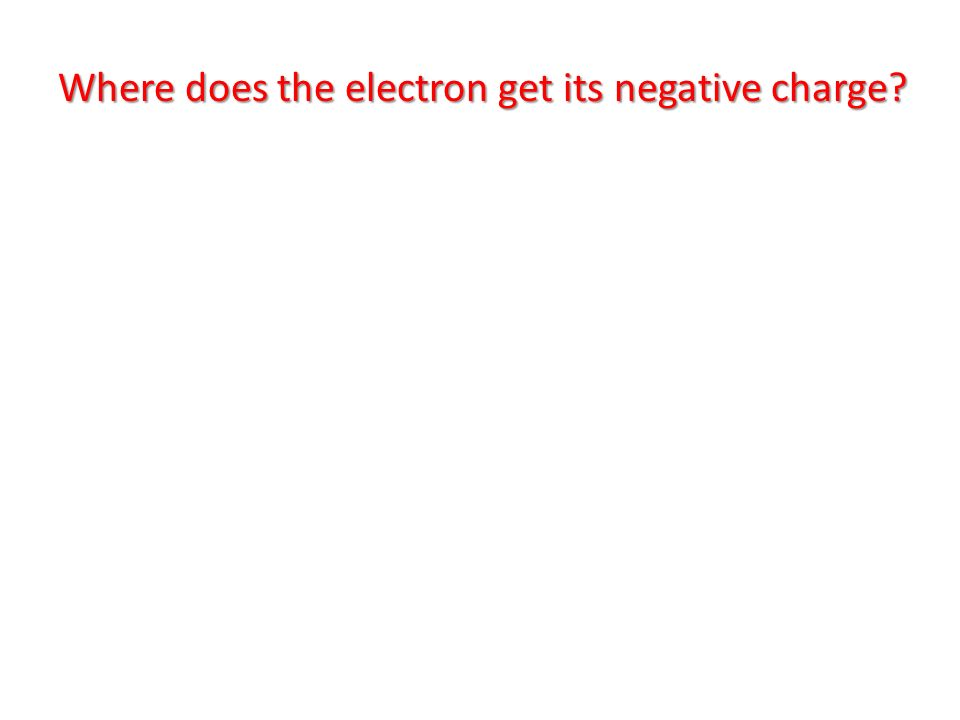Imagine if the electron's charge could be visibly seen, how would you creatively represent this concept visually? If the electron's charge could be visually represented, one creative way to depict this might be through a glowing aura or field surrounding the electron. Picture a tiny particle, the electron, with a bright, pulsing blue aura representing its negative charge. The intensity of the glow could vary to indicate the strength of the charge field. In a more artistic representation, streams or sparks of energy could emanate from the electron, swirling in dynamic patterns that reflect the electromagnetic interactions it engages in. This visual could be set against a contrasting background, such as a dark or starry space, to emphasize the electron's energy and importance in atomic structures. This sort of visual could be used in educational materials to make the abstract concept of charge more tangible and engaging. In a scientific setting, how else might we visually illustrate the consequences or interactions of an electron's charge? In a scientific setting, the consequences or interactions of an electron's charge could be illustrated using field lines in a diagram, showing its influence in an electric field. Another visual method could be through simulations depicting electrons moving within an atom, highlighting their interactions with protons and other electrons. Animated arrows could represent forces of attraction and repulsion. Additionally, color-coded diagrams could differentiate various charge magnitudes and types, providing a clear and comparative view of electrostatic interactions. Advanced visualizations might involve 3D models showing electron clouds representing areas of high probability density, which give more depth to understanding their behavior in atoms. 